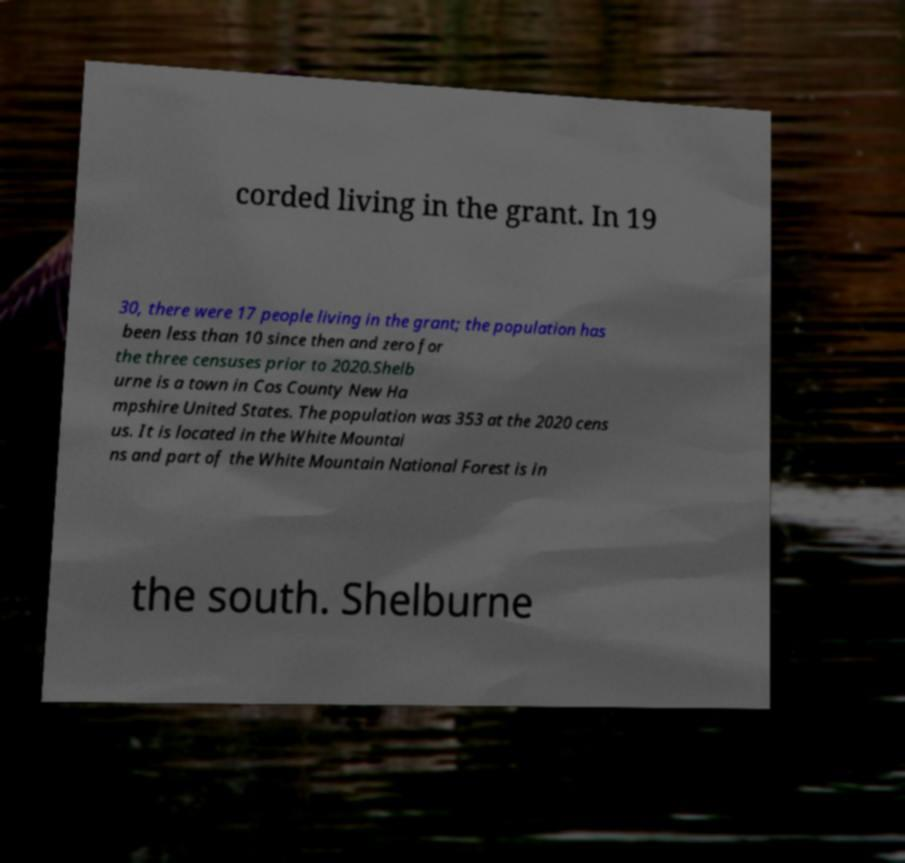Please identify and transcribe the text found in this image. corded living in the grant. In 19 30, there were 17 people living in the grant; the population has been less than 10 since then and zero for the three censuses prior to 2020.Shelb urne is a town in Cos County New Ha mpshire United States. The population was 353 at the 2020 cens us. It is located in the White Mountai ns and part of the White Mountain National Forest is in the south. Shelburne 